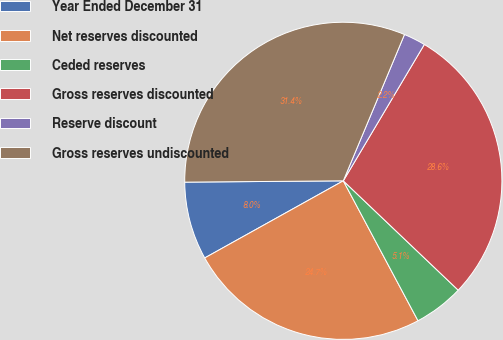<chart> <loc_0><loc_0><loc_500><loc_500><pie_chart><fcel>Year Ended December 31<fcel>Net reserves discounted<fcel>Ceded reserves<fcel>Gross reserves discounted<fcel>Reserve discount<fcel>Gross reserves undiscounted<nl><fcel>7.95%<fcel>24.72%<fcel>5.09%<fcel>28.57%<fcel>2.23%<fcel>31.43%<nl></chart> 